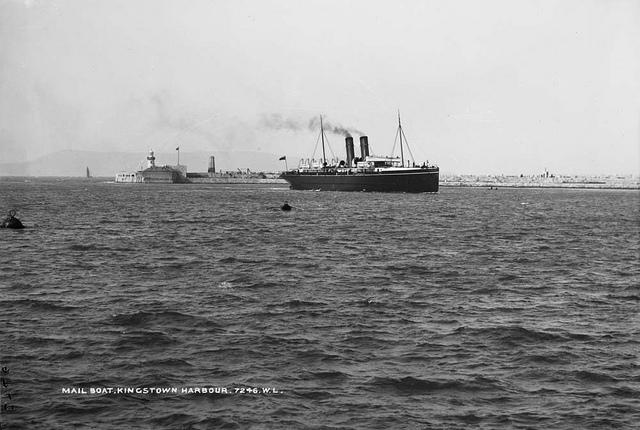Are there more than one buoy in the sea?
Keep it brief. Yes. Is the surf calm or turbulent?
Give a very brief answer. Turbulent. What is the shape of the large object in the background?
Quick response, please. Ship. Is this a steamboat?
Quick response, please. Yes. Where did this picture come from?
Short answer required. Kingstown harbour. Are there smaller boats around?
Answer briefly. No. What type of boat is that?
Write a very short answer. Ship. Is the ship letting out smoke?
Answer briefly. Yes. 